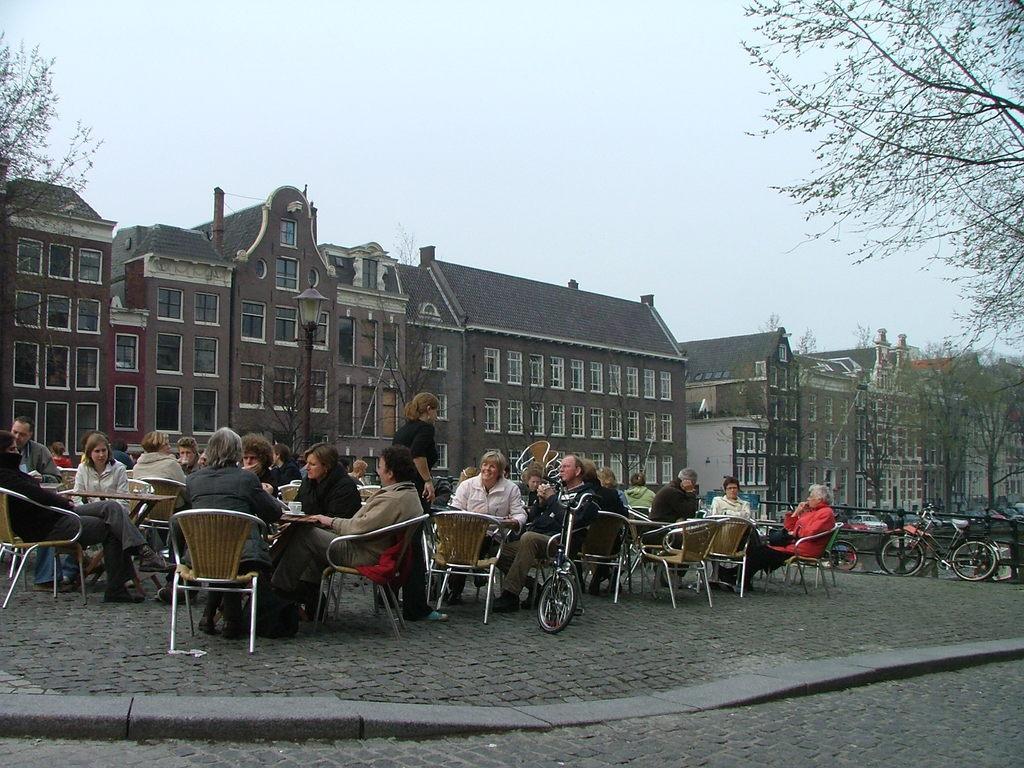In one or two sentences, can you explain what this image depicts? Most of persons are sitting on chairs. In-front of them there are table. Beside this chair there is a bicycle. Far there is a bicycle in-front of this fence. We can able to see buildings with windows. This lamp light with pole. We can able to see trees. In-between of this person's a woman is standing. 